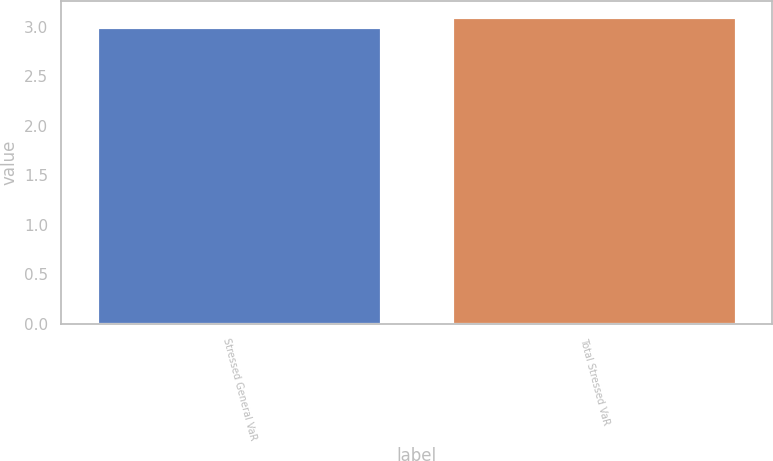Convert chart to OTSL. <chart><loc_0><loc_0><loc_500><loc_500><bar_chart><fcel>Stressed General VaR<fcel>Total Stressed VaR<nl><fcel>3<fcel>3.1<nl></chart> 